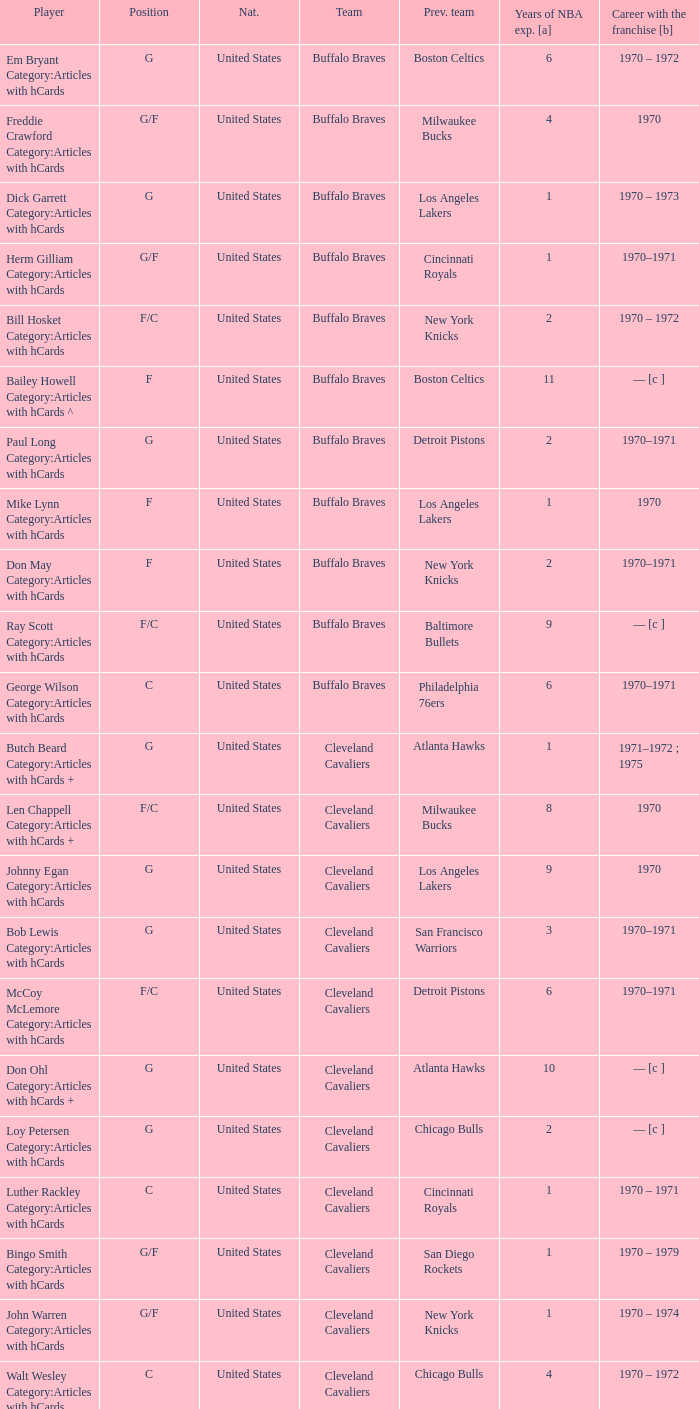Who is the player from the Buffalo Braves with the previous team Los Angeles Lakers and a career with the franchase in 1970? Mike Lynn Category:Articles with hCards. 